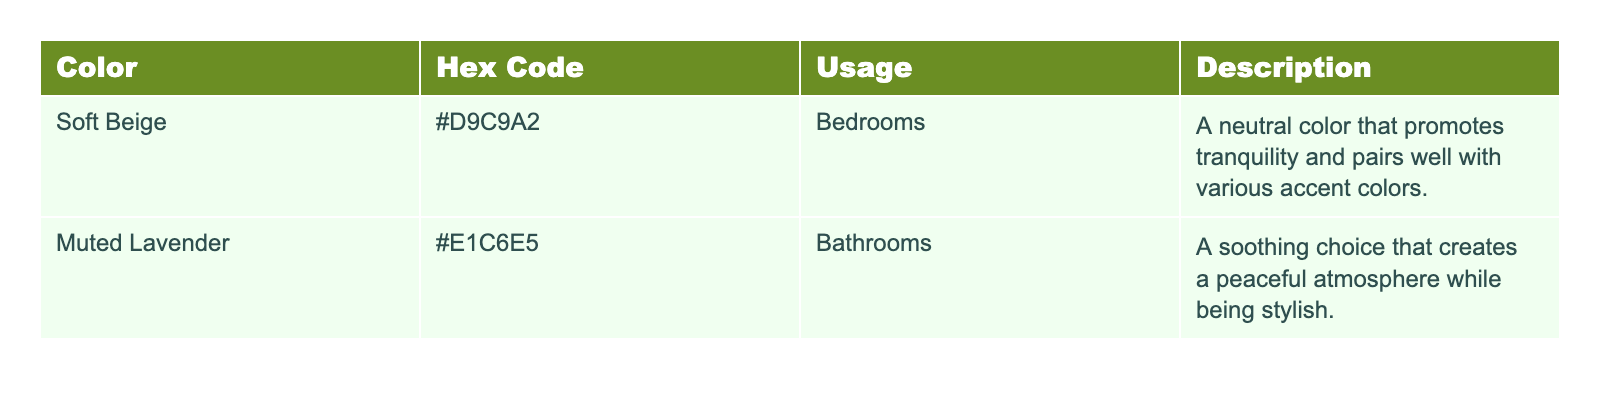What colors are used in bedrooms according to the table? The table lists "Soft Beige" as the color used in bedrooms under the "Usage" column.
Answer: Soft Beige Which color is used in bathrooms? Referring to the "Usage" column, "Muted Lavender" is indicated as the color for bathrooms.
Answer: Muted Lavender What is the hex code for Soft Beige? The hex code for Soft Beige is provided in the "Hex Code" column as #D9C9A2.
Answer: #D9C9A2 Does the table indicate that Muted Lavender is a neutral color? The table does not describe Muted Lavender as a neutral color; it specifies it as a soothing choice for bathrooms.
Answer: No Which color is suggested for promoting tranquility? The table specifically describes Soft Beige as a neutral color that promotes tranquility, so it is the suggested color.
Answer: Soft Beige Is the description for Soft Beige positive or negative? The description states that Soft Beige promotes tranquility and pairs well with other colors, indicating a positive quality.
Answer: Positive Which color has a more soothing description, Soft Beige or Muted Lavender? The table states that Muted Lavender creates a peaceful atmosphere while being stylish, which suggests it has a more soothing description compared to Soft Beige.
Answer: Muted Lavender Are both described colors used in specific rooms, and if so, which rooms? Yes, the table shows that Soft Beige is used in bedrooms and Muted Lavender is used in bathrooms, indicating their specific usage.
Answer: Yes, bedrooms and bathrooms What color has a hex code starting with “#E”? The hex code for Muted Lavender starts with “#E”, indicating it is the color corresponding to that code in the table.
Answer: Muted Lavender What is the combined number of rooms indicated in the usage column? The usage column mentions two different rooms: bedrooms and bathrooms; therefore, the combined count of unique rooms is 2.
Answer: 2 